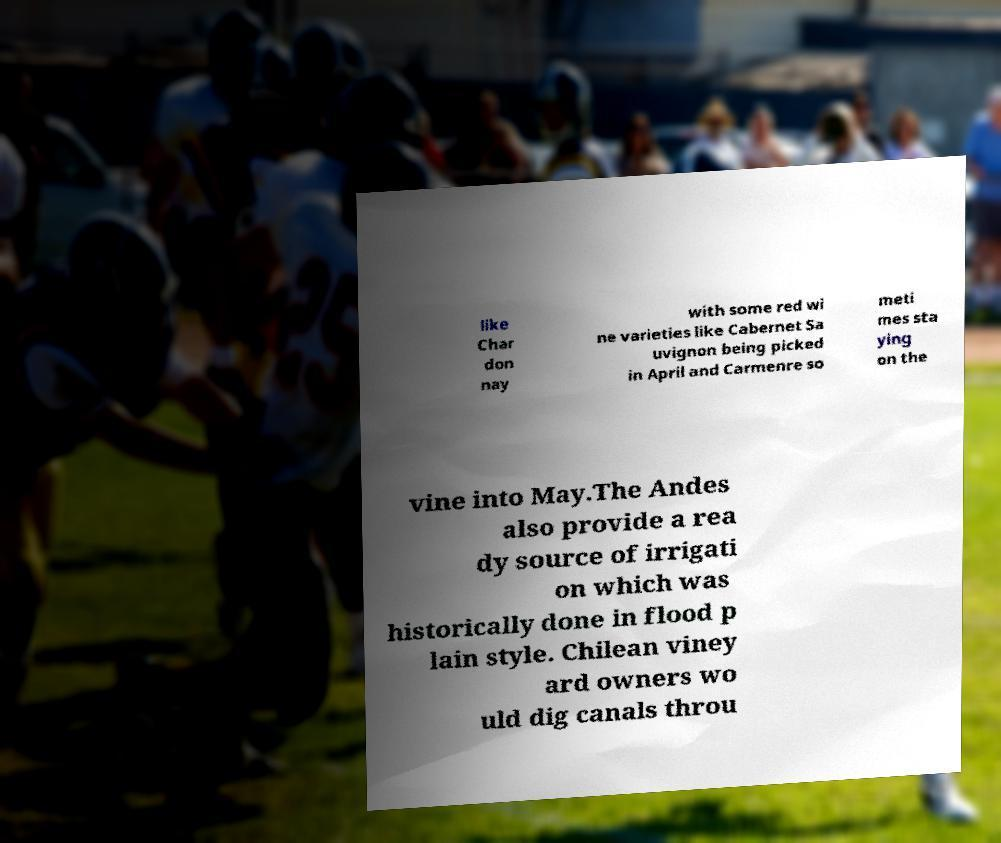Could you assist in decoding the text presented in this image and type it out clearly? like Char don nay with some red wi ne varieties like Cabernet Sa uvignon being picked in April and Carmenre so meti mes sta ying on the vine into May.The Andes also provide a rea dy source of irrigati on which was historically done in flood p lain style. Chilean viney ard owners wo uld dig canals throu 